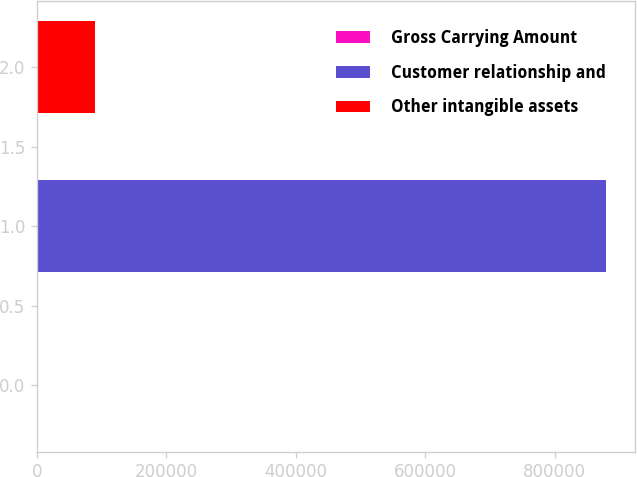Convert chart. <chart><loc_0><loc_0><loc_500><loc_500><bar_chart><fcel>Gross Carrying Amount<fcel>Customer relationship and<fcel>Other intangible assets<nl><fcel>2013<fcel>879378<fcel>89749.5<nl></chart> 